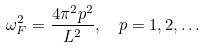Convert formula to latex. <formula><loc_0><loc_0><loc_500><loc_500>\omega _ { F } ^ { 2 } = \frac { 4 \pi ^ { 2 } p ^ { 2 } } { L ^ { 2 } } , \ \ p = 1 , 2 , \dots</formula> 